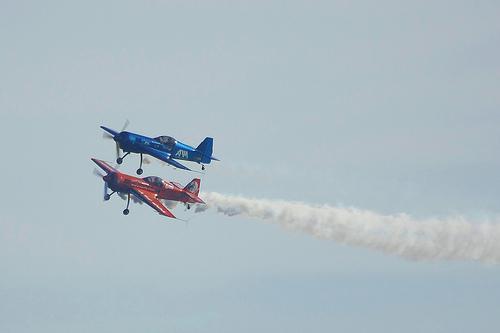How many planes are in the photo?
Give a very brief answer. 2. How many of the airplanes have entrails?
Give a very brief answer. 1. How many blue airplanes are in the image?
Give a very brief answer. 1. 